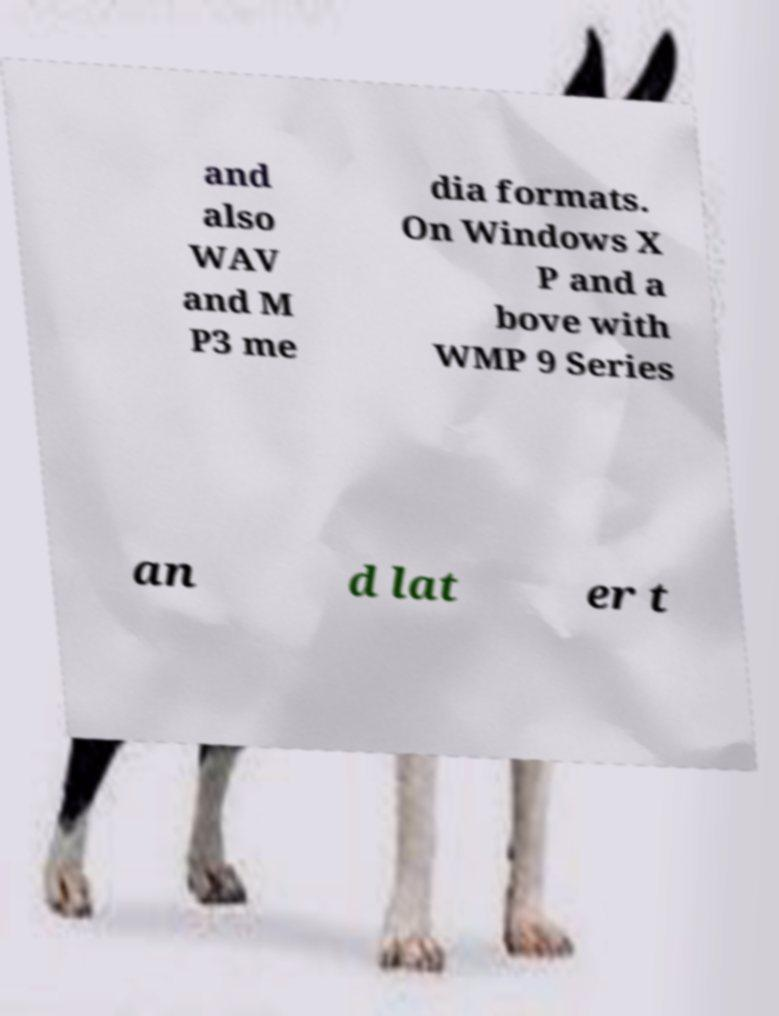There's text embedded in this image that I need extracted. Can you transcribe it verbatim? and also WAV and M P3 me dia formats. On Windows X P and a bove with WMP 9 Series an d lat er t 